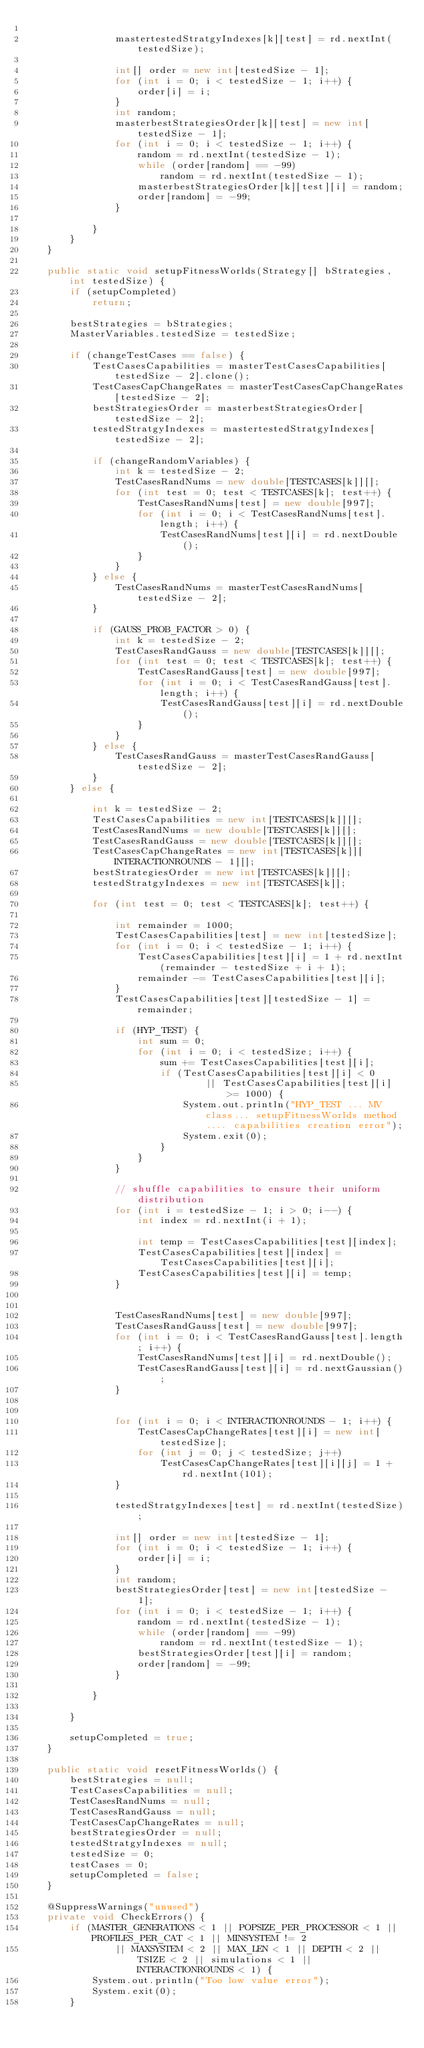Convert code to text. <code><loc_0><loc_0><loc_500><loc_500><_Java_>	
				mastertestedStratgyIndexes[k][test] = rd.nextInt(testedSize);
	
				int[] order = new int[testedSize - 1];
				for (int i = 0; i < testedSize - 1; i++) {
					order[i] = i;
				}
				int random;
				masterbestStrategiesOrder[k][test] = new int[testedSize - 1];
				for (int i = 0; i < testedSize - 1; i++) {
					random = rd.nextInt(testedSize - 1);
					while (order[random] == -99)
						random = rd.nextInt(testedSize - 1);
					masterbestStrategiesOrder[k][test][i] = random;
					order[random] = -99;
				}
	
			}
		}
	}

	public static void setupFitnessWorlds(Strategy[] bStrategies, int testedSize) {
		if (setupCompleted)
			return;
		
		bestStrategies = bStrategies;
		MasterVariables.testedSize = testedSize;

		if (changeTestCases == false) {
			TestCasesCapabilities = masterTestCasesCapabilities[testedSize - 2].clone();
			TestCasesCapChangeRates = masterTestCasesCapChangeRates[testedSize - 2];
			bestStrategiesOrder = masterbestStrategiesOrder[testedSize - 2];
			testedStratgyIndexes = mastertestedStratgyIndexes[testedSize - 2];

			if (changeRandomVariables) {
				int k = testedSize - 2;
				TestCasesRandNums = new double[TESTCASES[k]][];
				for (int test = 0; test < TESTCASES[k]; test++) {
					TestCasesRandNums[test] = new double[997];
					for (int i = 0; i < TestCasesRandNums[test].length; i++) {
						TestCasesRandNums[test][i] = rd.nextDouble();
					}
				}
			} else {
				TestCasesRandNums = masterTestCasesRandNums[testedSize - 2];
			}

			if (GAUSS_PROB_FACTOR > 0) {
				int k = testedSize - 2;
				TestCasesRandGauss = new double[TESTCASES[k]][];
				for (int test = 0; test < TESTCASES[k]; test++) {
					TestCasesRandGauss[test] = new double[997];
					for (int i = 0; i < TestCasesRandGauss[test].length; i++) {
						TestCasesRandGauss[test][i] = rd.nextDouble();
					}
				}
			} else {
				TestCasesRandGauss = masterTestCasesRandGauss[testedSize - 2];
			}
		} else {

			int k = testedSize - 2;
			TestCasesCapabilities = new int[TESTCASES[k]][];
			TestCasesRandNums = new double[TESTCASES[k]][]; 
			TestCasesRandGauss = new double[TESTCASES[k]][];
			TestCasesCapChangeRates = new int[TESTCASES[k]][INTERACTIONROUNDS - 1][];
			bestStrategiesOrder = new int[TESTCASES[k]][];
			testedStratgyIndexes = new int[TESTCASES[k]];

			for (int test = 0; test < TESTCASES[k]; test++) {
	
				int remainder = 1000;
				TestCasesCapabilities[test] = new int[testedSize];
				for (int i = 0; i < testedSize - 1; i++) {
					TestCasesCapabilities[test][i] = 1 + rd.nextInt(remainder - testedSize + i + 1);
					remainder -= TestCasesCapabilities[test][i];
				}
				TestCasesCapabilities[test][testedSize - 1] = remainder;
				
				if (HYP_TEST) {
					int sum = 0;
					for (int i = 0; i < testedSize; i++) {
						sum += TestCasesCapabilities[test][i];
						if (TestCasesCapabilities[test][i] < 0
								|| TestCasesCapabilities[test][i] >= 1000) {
							System.out.println("HYP_TEST ... MV class... setupFitnessWorlds method .... capabilities creation error");
							System.exit(0);
						}
					}
				}
	
				// shuffle capabilities to ensure their uniform distribution
				for (int i = testedSize - 1; i > 0; i--) {
					int index = rd.nextInt(i + 1);
	
					int temp = TestCasesCapabilities[test][index];
					TestCasesCapabilities[test][index] = TestCasesCapabilities[test][i];
					TestCasesCapabilities[test][i] = temp;
				}
	
				
				TestCasesRandNums[test] = new double[997];
				TestCasesRandGauss[test] = new double[997];
				for (int i = 0; i < TestCasesRandGauss[test].length; i++) {
					TestCasesRandNums[test][i] = rd.nextDouble();
					TestCasesRandGauss[test][i] = rd.nextGaussian();
				}
	
	
				for (int i = 0; i < INTERACTIONROUNDS - 1; i++) {
					TestCasesCapChangeRates[test][i] = new int[testedSize];
					for (int j = 0; j < testedSize; j++)
						TestCasesCapChangeRates[test][i][j] = 1 + rd.nextInt(101);
				}
	
				testedStratgyIndexes[test] = rd.nextInt(testedSize);
	
				int[] order = new int[testedSize - 1];
				for (int i = 0; i < testedSize - 1; i++) {
					order[i] = i;
				}
				int random;
				bestStrategiesOrder[test] = new int[testedSize - 1];
				for (int i = 0; i < testedSize - 1; i++) {
					random = rd.nextInt(testedSize - 1);
					while (order[random] == -99)
						random = rd.nextInt(testedSize - 1);
					bestStrategiesOrder[test][i] = random;
					order[random] = -99;
				}
	
			}
		
		}
		
		setupCompleted = true;
	}

	public static void resetFitnessWorlds() {
		bestStrategies = null;
		TestCasesCapabilities = null;
		TestCasesRandNums = null;
		TestCasesRandGauss = null;
		TestCasesCapChangeRates = null;
		bestStrategiesOrder = null;
		testedStratgyIndexes = null;
		testedSize = 0;
		testCases = 0;
		setupCompleted = false;
	}

	@SuppressWarnings("unused")
	private void CheckErrors() {
		if (MASTER_GENERATIONS < 1 || POPSIZE_PER_PROCESSOR < 1 || PROFILES_PER_CAT < 1 || MINSYSTEM != 2
				|| MAXSYSTEM < 2 || MAX_LEN < 1 || DEPTH < 2 || TSIZE < 2 || simulations < 1 || INTERACTIONROUNDS < 1) {
			System.out.println("Too low value error");
			System.exit(0);
		}
</code> 